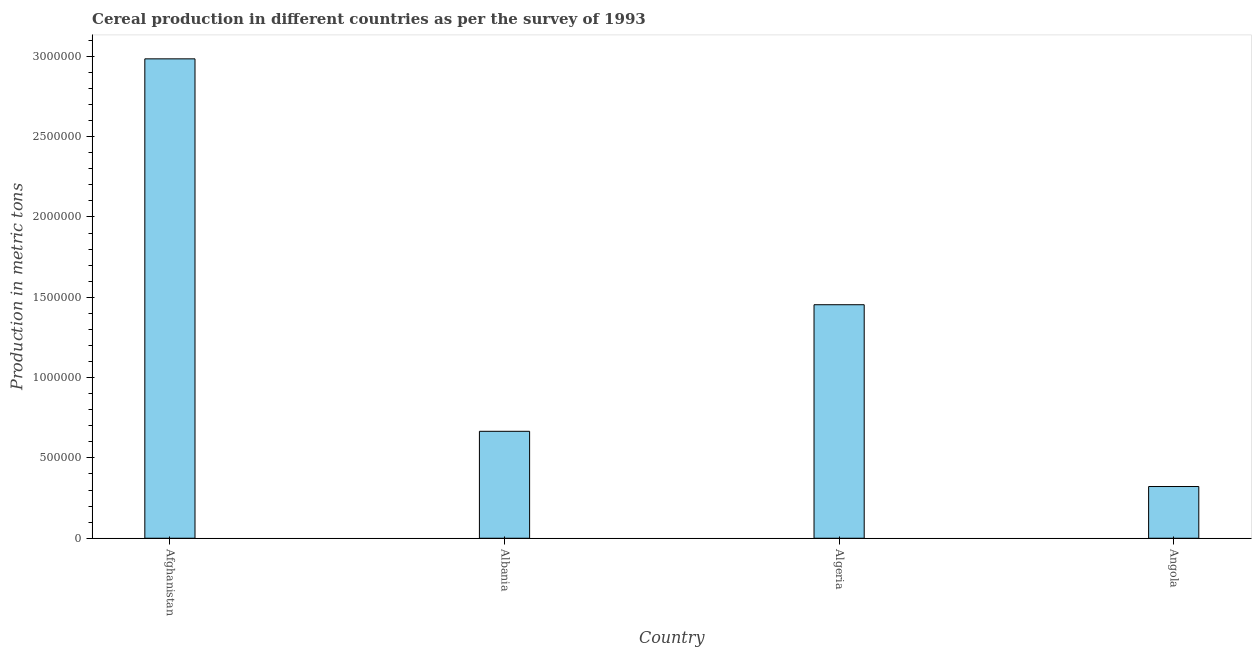What is the title of the graph?
Provide a succinct answer. Cereal production in different countries as per the survey of 1993. What is the label or title of the X-axis?
Your answer should be very brief. Country. What is the label or title of the Y-axis?
Your answer should be very brief. Production in metric tons. What is the cereal production in Algeria?
Make the answer very short. 1.45e+06. Across all countries, what is the maximum cereal production?
Offer a very short reply. 2.98e+06. Across all countries, what is the minimum cereal production?
Ensure brevity in your answer.  3.22e+05. In which country was the cereal production maximum?
Make the answer very short. Afghanistan. In which country was the cereal production minimum?
Make the answer very short. Angola. What is the sum of the cereal production?
Give a very brief answer. 5.43e+06. What is the difference between the cereal production in Afghanistan and Angola?
Ensure brevity in your answer.  2.66e+06. What is the average cereal production per country?
Your answer should be very brief. 1.36e+06. What is the median cereal production?
Your answer should be very brief. 1.06e+06. What is the ratio of the cereal production in Albania to that in Angola?
Your answer should be very brief. 2.07. What is the difference between the highest and the second highest cereal production?
Provide a succinct answer. 1.53e+06. What is the difference between the highest and the lowest cereal production?
Offer a very short reply. 2.66e+06. In how many countries, is the cereal production greater than the average cereal production taken over all countries?
Give a very brief answer. 2. How many bars are there?
Your answer should be compact. 4. How many countries are there in the graph?
Provide a short and direct response. 4. What is the difference between two consecutive major ticks on the Y-axis?
Provide a short and direct response. 5.00e+05. What is the Production in metric tons in Afghanistan?
Offer a terse response. 2.98e+06. What is the Production in metric tons of Albania?
Your answer should be compact. 6.66e+05. What is the Production in metric tons of Algeria?
Give a very brief answer. 1.45e+06. What is the Production in metric tons of Angola?
Offer a very short reply. 3.22e+05. What is the difference between the Production in metric tons in Afghanistan and Albania?
Your answer should be compact. 2.32e+06. What is the difference between the Production in metric tons in Afghanistan and Algeria?
Make the answer very short. 1.53e+06. What is the difference between the Production in metric tons in Afghanistan and Angola?
Keep it short and to the point. 2.66e+06. What is the difference between the Production in metric tons in Albania and Algeria?
Ensure brevity in your answer.  -7.88e+05. What is the difference between the Production in metric tons in Albania and Angola?
Your response must be concise. 3.44e+05. What is the difference between the Production in metric tons in Algeria and Angola?
Your answer should be compact. 1.13e+06. What is the ratio of the Production in metric tons in Afghanistan to that in Albania?
Keep it short and to the point. 4.48. What is the ratio of the Production in metric tons in Afghanistan to that in Algeria?
Keep it short and to the point. 2.05. What is the ratio of the Production in metric tons in Afghanistan to that in Angola?
Your answer should be very brief. 9.27. What is the ratio of the Production in metric tons in Albania to that in Algeria?
Make the answer very short. 0.46. What is the ratio of the Production in metric tons in Albania to that in Angola?
Offer a very short reply. 2.07. What is the ratio of the Production in metric tons in Algeria to that in Angola?
Give a very brief answer. 4.51. 